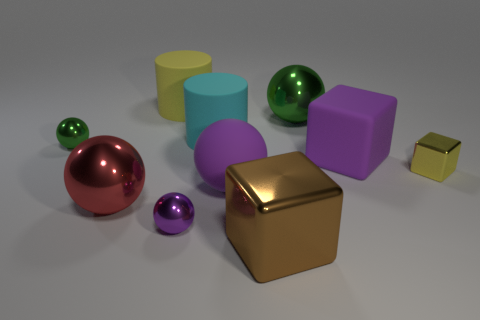Subtract all purple matte spheres. How many spheres are left? 4 Subtract all red balls. How many balls are left? 4 Subtract 1 spheres. How many spheres are left? 4 Subtract all cyan balls. Subtract all gray blocks. How many balls are left? 5 Subtract all cylinders. How many objects are left? 8 Add 9 purple metallic things. How many purple metallic things are left? 10 Add 9 cyan things. How many cyan things exist? 10 Subtract 1 purple blocks. How many objects are left? 9 Subtract all blue matte cylinders. Subtract all red metallic spheres. How many objects are left? 9 